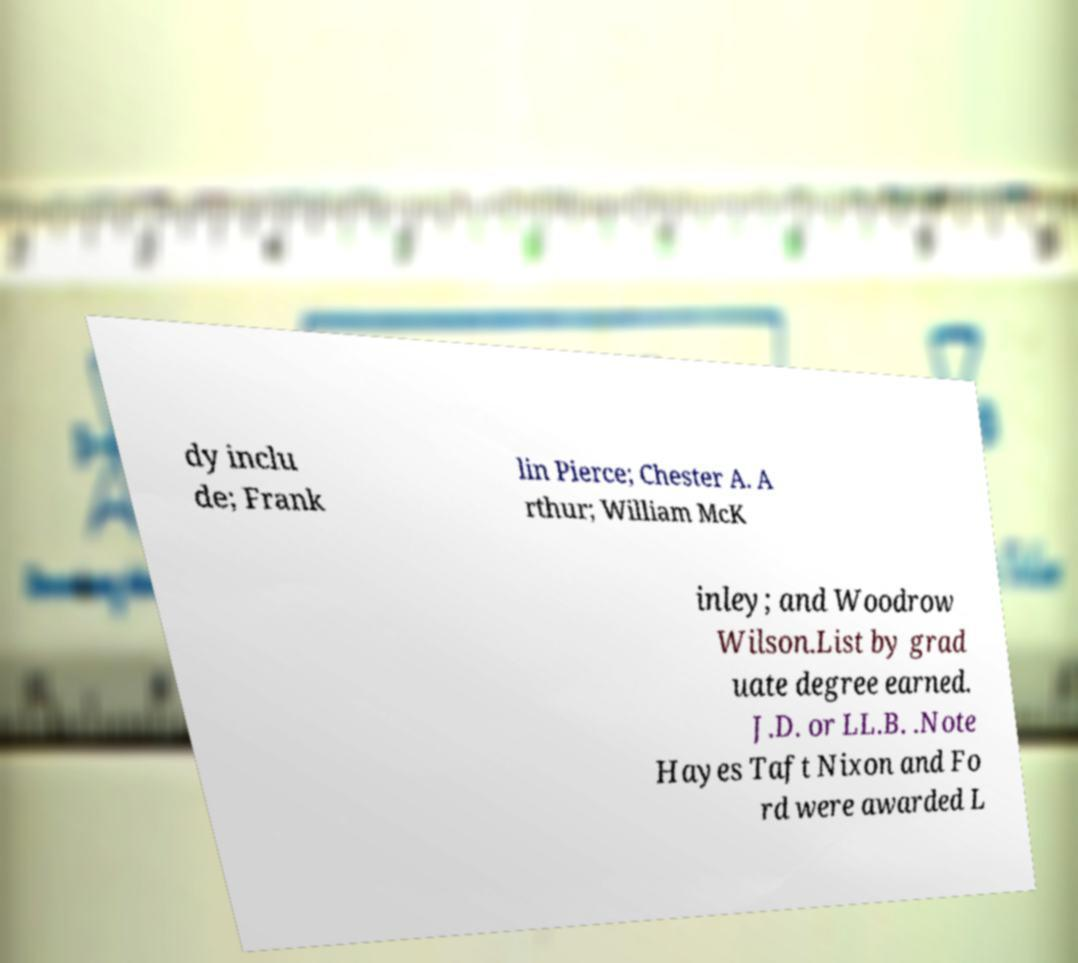For documentation purposes, I need the text within this image transcribed. Could you provide that? dy inclu de; Frank lin Pierce; Chester A. A rthur; William McK inley; and Woodrow Wilson.List by grad uate degree earned. J.D. or LL.B. .Note Hayes Taft Nixon and Fo rd were awarded L 